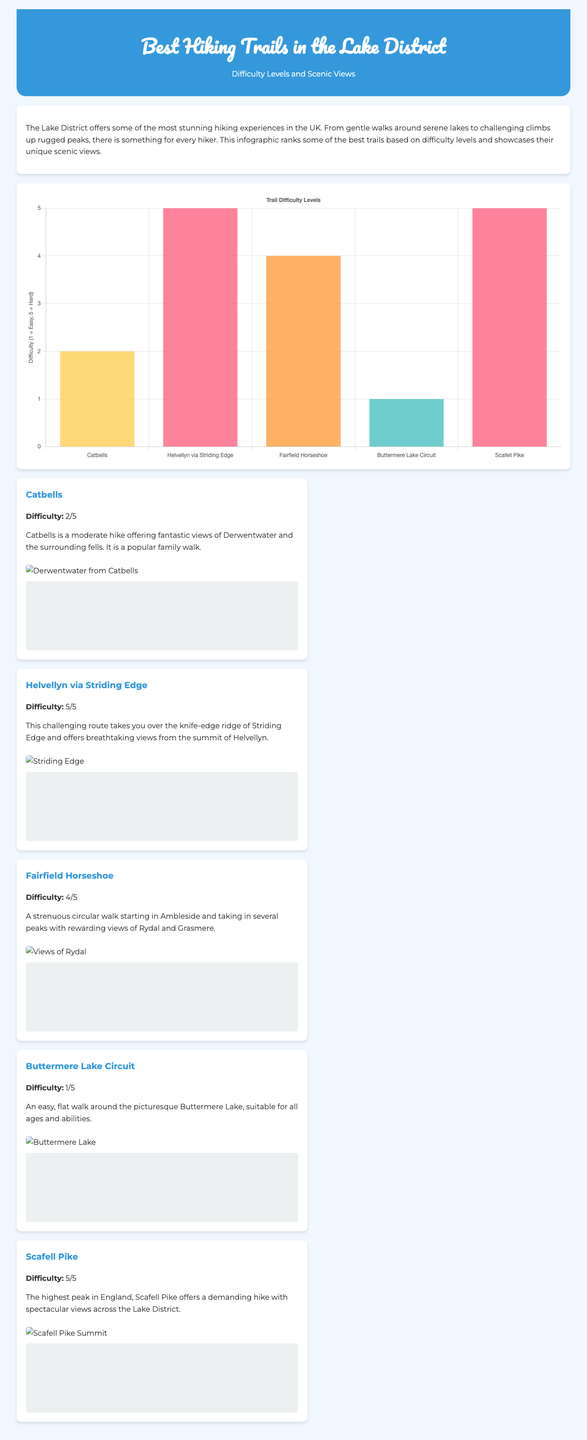What is the title of the infographic? The title is prominently displayed in the header section of the document, indicating the subject of the infographic.
Answer: Best Hiking Trails in the Lake District How many trails are featured in the infographic? The infographic provides details on a specific number of hiking trails, which can be counted in the trail details section.
Answer: 5 What is the highest difficulty rating among the trails? The difficulty ratings are displayed for each trail, allowing for an easy comparison to determine the maximum value.
Answer: 5 Which trail has the lowest difficulty level? The infographic ranks the trails based on their difficulty levels, making it straightforward to identify the least difficult one.
Answer: Buttermere Lake Circuit What is the difficulty level of the Fairfield Horseshoe trail? This information is clearly stated in the description of the Fairfield Horseshoe trail within the infographic.
Answer: 4/5 Which trail offers views of Derwentwater? The descriptions of the trails mention specific views offered by each one, allowing readers to find relevant scenic information.
Answer: Catbells How many trails have a difficulty level of 5? The infographic lists the difficulty levels, making it easy to count how many trails fall within the highest category.
Answer: 2 What type of chart is used to represent the difficulty levels? The document specifically uses a chart type that shows comparisons of the difficulty levels across the trails.
Answer: Bar Chart Which trail has an elevation profile reaching 978 meters? The elevation profiles for each trail provide specific elevation details, helpful for identifying peaks in variety.
Answer: Scafell Pike 